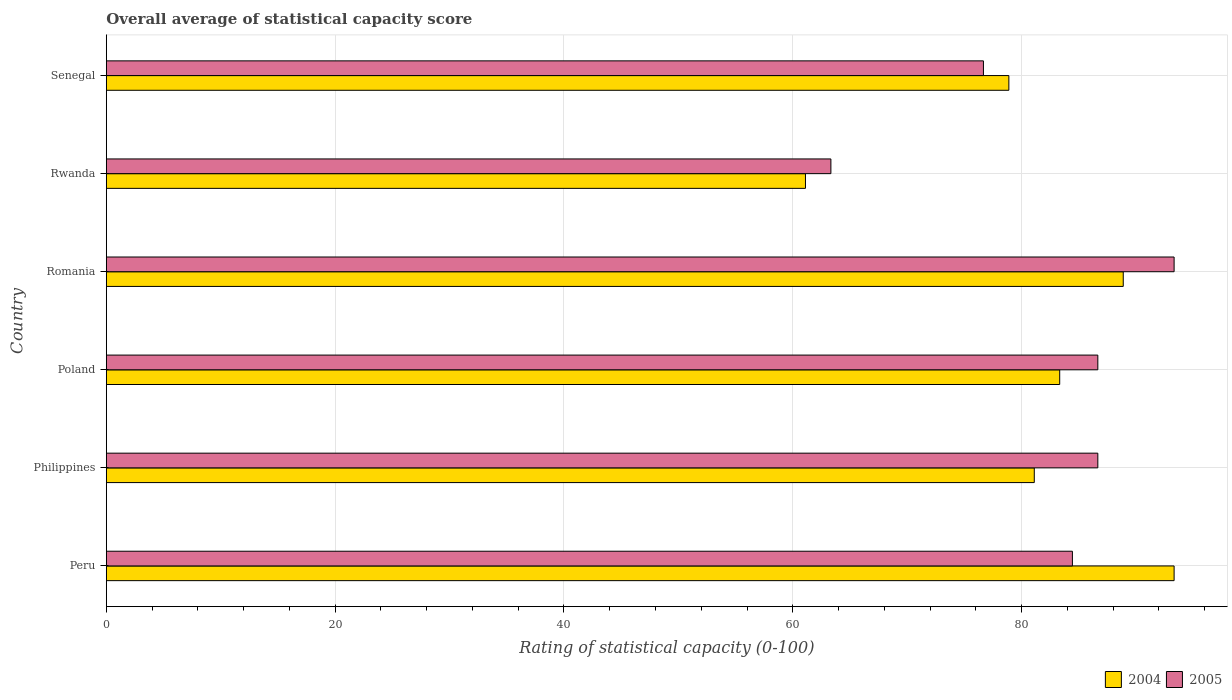How many bars are there on the 1st tick from the top?
Offer a very short reply. 2. How many bars are there on the 6th tick from the bottom?
Keep it short and to the point. 2. What is the label of the 3rd group of bars from the top?
Provide a succinct answer. Romania. In how many cases, is the number of bars for a given country not equal to the number of legend labels?
Provide a short and direct response. 0. What is the rating of statistical capacity in 2004 in Rwanda?
Give a very brief answer. 61.11. Across all countries, what is the maximum rating of statistical capacity in 2005?
Keep it short and to the point. 93.33. Across all countries, what is the minimum rating of statistical capacity in 2004?
Make the answer very short. 61.11. In which country was the rating of statistical capacity in 2005 maximum?
Your answer should be compact. Romania. In which country was the rating of statistical capacity in 2005 minimum?
Give a very brief answer. Rwanda. What is the total rating of statistical capacity in 2005 in the graph?
Your response must be concise. 491.11. What is the difference between the rating of statistical capacity in 2005 in Philippines and that in Romania?
Offer a terse response. -6.67. What is the difference between the rating of statistical capacity in 2005 in Rwanda and the rating of statistical capacity in 2004 in Peru?
Provide a short and direct response. -30. What is the average rating of statistical capacity in 2005 per country?
Give a very brief answer. 81.85. What is the difference between the rating of statistical capacity in 2004 and rating of statistical capacity in 2005 in Poland?
Your answer should be compact. -3.33. In how many countries, is the rating of statistical capacity in 2005 greater than 28 ?
Keep it short and to the point. 6. What is the ratio of the rating of statistical capacity in 2004 in Poland to that in Rwanda?
Provide a short and direct response. 1.36. Is the difference between the rating of statistical capacity in 2004 in Peru and Rwanda greater than the difference between the rating of statistical capacity in 2005 in Peru and Rwanda?
Your answer should be very brief. Yes. What is the difference between the highest and the second highest rating of statistical capacity in 2004?
Make the answer very short. 4.44. What is the difference between the highest and the lowest rating of statistical capacity in 2004?
Ensure brevity in your answer.  32.22. What does the 1st bar from the top in Romania represents?
Ensure brevity in your answer.  2005. What does the 1st bar from the bottom in Poland represents?
Make the answer very short. 2004. How many bars are there?
Provide a short and direct response. 12. Does the graph contain any zero values?
Make the answer very short. No. Where does the legend appear in the graph?
Make the answer very short. Bottom right. What is the title of the graph?
Your answer should be very brief. Overall average of statistical capacity score. Does "1990" appear as one of the legend labels in the graph?
Give a very brief answer. No. What is the label or title of the X-axis?
Make the answer very short. Rating of statistical capacity (0-100). What is the label or title of the Y-axis?
Make the answer very short. Country. What is the Rating of statistical capacity (0-100) of 2004 in Peru?
Your answer should be compact. 93.33. What is the Rating of statistical capacity (0-100) of 2005 in Peru?
Give a very brief answer. 84.44. What is the Rating of statistical capacity (0-100) in 2004 in Philippines?
Ensure brevity in your answer.  81.11. What is the Rating of statistical capacity (0-100) of 2005 in Philippines?
Provide a succinct answer. 86.67. What is the Rating of statistical capacity (0-100) of 2004 in Poland?
Ensure brevity in your answer.  83.33. What is the Rating of statistical capacity (0-100) of 2005 in Poland?
Provide a succinct answer. 86.67. What is the Rating of statistical capacity (0-100) in 2004 in Romania?
Ensure brevity in your answer.  88.89. What is the Rating of statistical capacity (0-100) in 2005 in Romania?
Provide a short and direct response. 93.33. What is the Rating of statistical capacity (0-100) of 2004 in Rwanda?
Your answer should be compact. 61.11. What is the Rating of statistical capacity (0-100) of 2005 in Rwanda?
Provide a short and direct response. 63.33. What is the Rating of statistical capacity (0-100) of 2004 in Senegal?
Ensure brevity in your answer.  78.89. What is the Rating of statistical capacity (0-100) in 2005 in Senegal?
Keep it short and to the point. 76.67. Across all countries, what is the maximum Rating of statistical capacity (0-100) in 2004?
Keep it short and to the point. 93.33. Across all countries, what is the maximum Rating of statistical capacity (0-100) in 2005?
Provide a short and direct response. 93.33. Across all countries, what is the minimum Rating of statistical capacity (0-100) of 2004?
Provide a succinct answer. 61.11. Across all countries, what is the minimum Rating of statistical capacity (0-100) in 2005?
Make the answer very short. 63.33. What is the total Rating of statistical capacity (0-100) in 2004 in the graph?
Your answer should be compact. 486.67. What is the total Rating of statistical capacity (0-100) of 2005 in the graph?
Give a very brief answer. 491.11. What is the difference between the Rating of statistical capacity (0-100) in 2004 in Peru and that in Philippines?
Make the answer very short. 12.22. What is the difference between the Rating of statistical capacity (0-100) in 2005 in Peru and that in Philippines?
Your answer should be compact. -2.22. What is the difference between the Rating of statistical capacity (0-100) of 2005 in Peru and that in Poland?
Give a very brief answer. -2.22. What is the difference between the Rating of statistical capacity (0-100) of 2004 in Peru and that in Romania?
Your answer should be compact. 4.44. What is the difference between the Rating of statistical capacity (0-100) in 2005 in Peru and that in Romania?
Provide a short and direct response. -8.89. What is the difference between the Rating of statistical capacity (0-100) of 2004 in Peru and that in Rwanda?
Your answer should be very brief. 32.22. What is the difference between the Rating of statistical capacity (0-100) of 2005 in Peru and that in Rwanda?
Provide a succinct answer. 21.11. What is the difference between the Rating of statistical capacity (0-100) of 2004 in Peru and that in Senegal?
Give a very brief answer. 14.44. What is the difference between the Rating of statistical capacity (0-100) in 2005 in Peru and that in Senegal?
Your answer should be compact. 7.78. What is the difference between the Rating of statistical capacity (0-100) in 2004 in Philippines and that in Poland?
Make the answer very short. -2.22. What is the difference between the Rating of statistical capacity (0-100) in 2004 in Philippines and that in Romania?
Keep it short and to the point. -7.78. What is the difference between the Rating of statistical capacity (0-100) in 2005 in Philippines and that in Romania?
Keep it short and to the point. -6.67. What is the difference between the Rating of statistical capacity (0-100) in 2005 in Philippines and that in Rwanda?
Give a very brief answer. 23.33. What is the difference between the Rating of statistical capacity (0-100) of 2004 in Philippines and that in Senegal?
Give a very brief answer. 2.22. What is the difference between the Rating of statistical capacity (0-100) of 2005 in Philippines and that in Senegal?
Offer a terse response. 10. What is the difference between the Rating of statistical capacity (0-100) in 2004 in Poland and that in Romania?
Give a very brief answer. -5.56. What is the difference between the Rating of statistical capacity (0-100) of 2005 in Poland and that in Romania?
Offer a terse response. -6.67. What is the difference between the Rating of statistical capacity (0-100) of 2004 in Poland and that in Rwanda?
Your response must be concise. 22.22. What is the difference between the Rating of statistical capacity (0-100) in 2005 in Poland and that in Rwanda?
Keep it short and to the point. 23.33. What is the difference between the Rating of statistical capacity (0-100) of 2004 in Poland and that in Senegal?
Your answer should be compact. 4.44. What is the difference between the Rating of statistical capacity (0-100) in 2005 in Poland and that in Senegal?
Offer a terse response. 10. What is the difference between the Rating of statistical capacity (0-100) of 2004 in Romania and that in Rwanda?
Offer a terse response. 27.78. What is the difference between the Rating of statistical capacity (0-100) in 2005 in Romania and that in Rwanda?
Provide a succinct answer. 30. What is the difference between the Rating of statistical capacity (0-100) of 2004 in Romania and that in Senegal?
Keep it short and to the point. 10. What is the difference between the Rating of statistical capacity (0-100) in 2005 in Romania and that in Senegal?
Provide a succinct answer. 16.67. What is the difference between the Rating of statistical capacity (0-100) in 2004 in Rwanda and that in Senegal?
Keep it short and to the point. -17.78. What is the difference between the Rating of statistical capacity (0-100) in 2005 in Rwanda and that in Senegal?
Provide a succinct answer. -13.33. What is the difference between the Rating of statistical capacity (0-100) in 2004 in Peru and the Rating of statistical capacity (0-100) in 2005 in Philippines?
Make the answer very short. 6.67. What is the difference between the Rating of statistical capacity (0-100) in 2004 in Peru and the Rating of statistical capacity (0-100) in 2005 in Poland?
Offer a terse response. 6.67. What is the difference between the Rating of statistical capacity (0-100) of 2004 in Peru and the Rating of statistical capacity (0-100) of 2005 in Romania?
Your answer should be very brief. 0. What is the difference between the Rating of statistical capacity (0-100) of 2004 in Peru and the Rating of statistical capacity (0-100) of 2005 in Rwanda?
Give a very brief answer. 30. What is the difference between the Rating of statistical capacity (0-100) in 2004 in Peru and the Rating of statistical capacity (0-100) in 2005 in Senegal?
Your answer should be compact. 16.67. What is the difference between the Rating of statistical capacity (0-100) in 2004 in Philippines and the Rating of statistical capacity (0-100) in 2005 in Poland?
Ensure brevity in your answer.  -5.56. What is the difference between the Rating of statistical capacity (0-100) of 2004 in Philippines and the Rating of statistical capacity (0-100) of 2005 in Romania?
Offer a very short reply. -12.22. What is the difference between the Rating of statistical capacity (0-100) of 2004 in Philippines and the Rating of statistical capacity (0-100) of 2005 in Rwanda?
Provide a short and direct response. 17.78. What is the difference between the Rating of statistical capacity (0-100) of 2004 in Philippines and the Rating of statistical capacity (0-100) of 2005 in Senegal?
Offer a terse response. 4.44. What is the difference between the Rating of statistical capacity (0-100) in 2004 in Poland and the Rating of statistical capacity (0-100) in 2005 in Romania?
Offer a terse response. -10. What is the difference between the Rating of statistical capacity (0-100) of 2004 in Poland and the Rating of statistical capacity (0-100) of 2005 in Senegal?
Your response must be concise. 6.67. What is the difference between the Rating of statistical capacity (0-100) in 2004 in Romania and the Rating of statistical capacity (0-100) in 2005 in Rwanda?
Offer a terse response. 25.56. What is the difference between the Rating of statistical capacity (0-100) in 2004 in Romania and the Rating of statistical capacity (0-100) in 2005 in Senegal?
Offer a very short reply. 12.22. What is the difference between the Rating of statistical capacity (0-100) in 2004 in Rwanda and the Rating of statistical capacity (0-100) in 2005 in Senegal?
Give a very brief answer. -15.56. What is the average Rating of statistical capacity (0-100) in 2004 per country?
Provide a short and direct response. 81.11. What is the average Rating of statistical capacity (0-100) in 2005 per country?
Give a very brief answer. 81.85. What is the difference between the Rating of statistical capacity (0-100) of 2004 and Rating of statistical capacity (0-100) of 2005 in Peru?
Make the answer very short. 8.89. What is the difference between the Rating of statistical capacity (0-100) in 2004 and Rating of statistical capacity (0-100) in 2005 in Philippines?
Provide a succinct answer. -5.56. What is the difference between the Rating of statistical capacity (0-100) of 2004 and Rating of statistical capacity (0-100) of 2005 in Romania?
Your answer should be very brief. -4.44. What is the difference between the Rating of statistical capacity (0-100) in 2004 and Rating of statistical capacity (0-100) in 2005 in Rwanda?
Offer a very short reply. -2.22. What is the difference between the Rating of statistical capacity (0-100) of 2004 and Rating of statistical capacity (0-100) of 2005 in Senegal?
Your answer should be very brief. 2.22. What is the ratio of the Rating of statistical capacity (0-100) in 2004 in Peru to that in Philippines?
Keep it short and to the point. 1.15. What is the ratio of the Rating of statistical capacity (0-100) of 2005 in Peru to that in Philippines?
Provide a succinct answer. 0.97. What is the ratio of the Rating of statistical capacity (0-100) of 2004 in Peru to that in Poland?
Your response must be concise. 1.12. What is the ratio of the Rating of statistical capacity (0-100) of 2005 in Peru to that in Poland?
Provide a succinct answer. 0.97. What is the ratio of the Rating of statistical capacity (0-100) of 2005 in Peru to that in Romania?
Offer a very short reply. 0.9. What is the ratio of the Rating of statistical capacity (0-100) in 2004 in Peru to that in Rwanda?
Offer a very short reply. 1.53. What is the ratio of the Rating of statistical capacity (0-100) in 2004 in Peru to that in Senegal?
Make the answer very short. 1.18. What is the ratio of the Rating of statistical capacity (0-100) in 2005 in Peru to that in Senegal?
Your answer should be compact. 1.1. What is the ratio of the Rating of statistical capacity (0-100) in 2004 in Philippines to that in Poland?
Your response must be concise. 0.97. What is the ratio of the Rating of statistical capacity (0-100) of 2004 in Philippines to that in Romania?
Provide a succinct answer. 0.91. What is the ratio of the Rating of statistical capacity (0-100) of 2005 in Philippines to that in Romania?
Ensure brevity in your answer.  0.93. What is the ratio of the Rating of statistical capacity (0-100) of 2004 in Philippines to that in Rwanda?
Your answer should be compact. 1.33. What is the ratio of the Rating of statistical capacity (0-100) in 2005 in Philippines to that in Rwanda?
Offer a very short reply. 1.37. What is the ratio of the Rating of statistical capacity (0-100) in 2004 in Philippines to that in Senegal?
Offer a very short reply. 1.03. What is the ratio of the Rating of statistical capacity (0-100) in 2005 in Philippines to that in Senegal?
Make the answer very short. 1.13. What is the ratio of the Rating of statistical capacity (0-100) in 2004 in Poland to that in Rwanda?
Give a very brief answer. 1.36. What is the ratio of the Rating of statistical capacity (0-100) in 2005 in Poland to that in Rwanda?
Your answer should be very brief. 1.37. What is the ratio of the Rating of statistical capacity (0-100) of 2004 in Poland to that in Senegal?
Keep it short and to the point. 1.06. What is the ratio of the Rating of statistical capacity (0-100) of 2005 in Poland to that in Senegal?
Provide a succinct answer. 1.13. What is the ratio of the Rating of statistical capacity (0-100) of 2004 in Romania to that in Rwanda?
Offer a terse response. 1.45. What is the ratio of the Rating of statistical capacity (0-100) in 2005 in Romania to that in Rwanda?
Provide a short and direct response. 1.47. What is the ratio of the Rating of statistical capacity (0-100) of 2004 in Romania to that in Senegal?
Your answer should be compact. 1.13. What is the ratio of the Rating of statistical capacity (0-100) of 2005 in Romania to that in Senegal?
Give a very brief answer. 1.22. What is the ratio of the Rating of statistical capacity (0-100) of 2004 in Rwanda to that in Senegal?
Give a very brief answer. 0.77. What is the ratio of the Rating of statistical capacity (0-100) of 2005 in Rwanda to that in Senegal?
Make the answer very short. 0.83. What is the difference between the highest and the second highest Rating of statistical capacity (0-100) of 2004?
Make the answer very short. 4.44. What is the difference between the highest and the second highest Rating of statistical capacity (0-100) of 2005?
Keep it short and to the point. 6.67. What is the difference between the highest and the lowest Rating of statistical capacity (0-100) in 2004?
Make the answer very short. 32.22. What is the difference between the highest and the lowest Rating of statistical capacity (0-100) in 2005?
Provide a succinct answer. 30. 